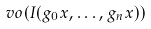<formula> <loc_0><loc_0><loc_500><loc_500>\ v o ( I ( g _ { 0 } x , \dots , g _ { n } x ) )</formula> 